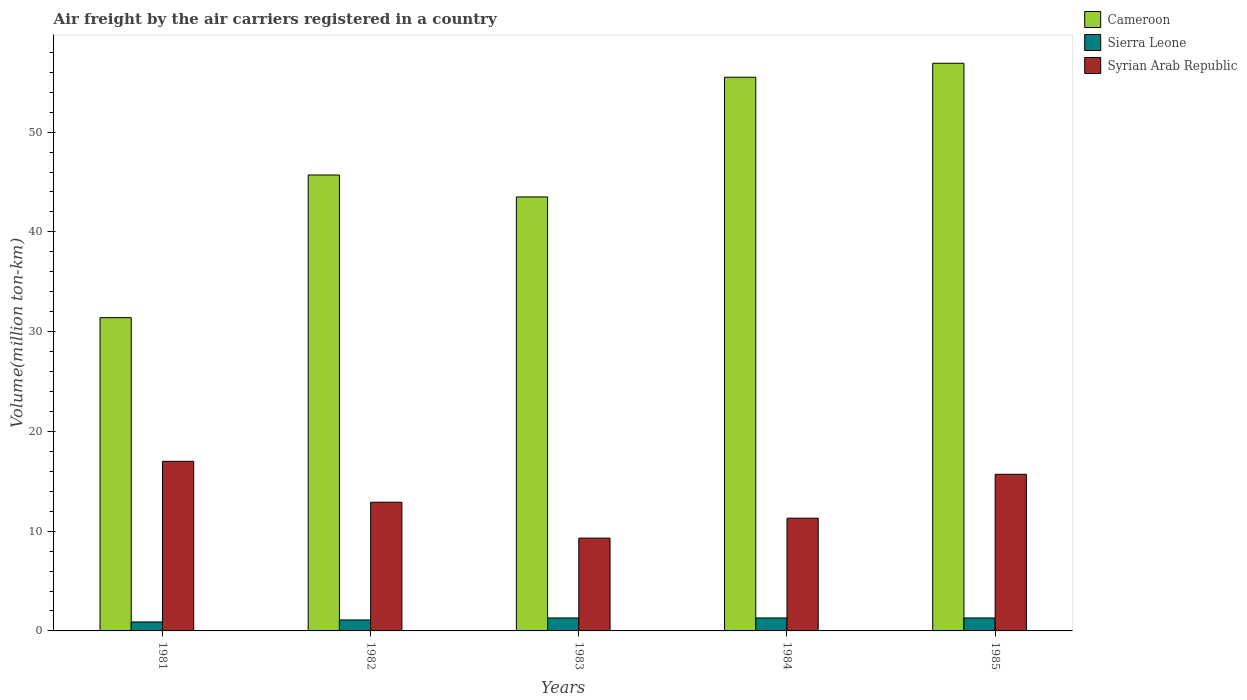How many different coloured bars are there?
Provide a short and direct response. 3. Are the number of bars per tick equal to the number of legend labels?
Provide a short and direct response. Yes. Are the number of bars on each tick of the X-axis equal?
Provide a short and direct response. Yes. How many bars are there on the 4th tick from the left?
Provide a short and direct response. 3. How many bars are there on the 1st tick from the right?
Your response must be concise. 3. What is the label of the 1st group of bars from the left?
Offer a terse response. 1981. In how many cases, is the number of bars for a given year not equal to the number of legend labels?
Your answer should be very brief. 0. What is the volume of the air carriers in Sierra Leone in 1984?
Provide a succinct answer. 1.3. Across all years, what is the maximum volume of the air carriers in Syrian Arab Republic?
Offer a very short reply. 17. Across all years, what is the minimum volume of the air carriers in Cameroon?
Offer a very short reply. 31.4. In which year was the volume of the air carriers in Sierra Leone maximum?
Your answer should be very brief. 1983. In which year was the volume of the air carriers in Cameroon minimum?
Offer a terse response. 1981. What is the total volume of the air carriers in Sierra Leone in the graph?
Your answer should be very brief. 5.9. What is the difference between the volume of the air carriers in Syrian Arab Republic in 1983 and that in 1984?
Offer a terse response. -2. What is the difference between the volume of the air carriers in Syrian Arab Republic in 1985 and the volume of the air carriers in Cameroon in 1984?
Your answer should be compact. -39.8. What is the average volume of the air carriers in Sierra Leone per year?
Offer a very short reply. 1.18. In the year 1984, what is the difference between the volume of the air carriers in Syrian Arab Republic and volume of the air carriers in Sierra Leone?
Your answer should be compact. 10. What is the ratio of the volume of the air carriers in Cameroon in 1981 to that in 1984?
Your response must be concise. 0.57. Is the difference between the volume of the air carriers in Syrian Arab Republic in 1981 and 1983 greater than the difference between the volume of the air carriers in Sierra Leone in 1981 and 1983?
Make the answer very short. Yes. What is the difference between the highest and the second highest volume of the air carriers in Syrian Arab Republic?
Offer a very short reply. 1.3. What is the difference between the highest and the lowest volume of the air carriers in Sierra Leone?
Your answer should be compact. 0.4. Is the sum of the volume of the air carriers in Sierra Leone in 1983 and 1985 greater than the maximum volume of the air carriers in Syrian Arab Republic across all years?
Give a very brief answer. No. What does the 2nd bar from the left in 1981 represents?
Your response must be concise. Sierra Leone. What does the 1st bar from the right in 1982 represents?
Your answer should be very brief. Syrian Arab Republic. Is it the case that in every year, the sum of the volume of the air carriers in Cameroon and volume of the air carriers in Syrian Arab Republic is greater than the volume of the air carriers in Sierra Leone?
Your answer should be very brief. Yes. How many bars are there?
Provide a short and direct response. 15. What is the difference between two consecutive major ticks on the Y-axis?
Your response must be concise. 10. Are the values on the major ticks of Y-axis written in scientific E-notation?
Provide a short and direct response. No. Does the graph contain any zero values?
Make the answer very short. No. Where does the legend appear in the graph?
Ensure brevity in your answer.  Top right. How many legend labels are there?
Give a very brief answer. 3. How are the legend labels stacked?
Your answer should be very brief. Vertical. What is the title of the graph?
Ensure brevity in your answer.  Air freight by the air carriers registered in a country. What is the label or title of the Y-axis?
Offer a terse response. Volume(million ton-km). What is the Volume(million ton-km) in Cameroon in 1981?
Your answer should be compact. 31.4. What is the Volume(million ton-km) of Sierra Leone in 1981?
Give a very brief answer. 0.9. What is the Volume(million ton-km) of Syrian Arab Republic in 1981?
Ensure brevity in your answer.  17. What is the Volume(million ton-km) in Cameroon in 1982?
Offer a terse response. 45.7. What is the Volume(million ton-km) in Sierra Leone in 1982?
Offer a terse response. 1.1. What is the Volume(million ton-km) in Syrian Arab Republic in 1982?
Provide a short and direct response. 12.9. What is the Volume(million ton-km) of Cameroon in 1983?
Your answer should be very brief. 43.5. What is the Volume(million ton-km) of Sierra Leone in 1983?
Your answer should be very brief. 1.3. What is the Volume(million ton-km) in Syrian Arab Republic in 1983?
Ensure brevity in your answer.  9.3. What is the Volume(million ton-km) of Cameroon in 1984?
Your answer should be compact. 55.5. What is the Volume(million ton-km) of Sierra Leone in 1984?
Your response must be concise. 1.3. What is the Volume(million ton-km) in Syrian Arab Republic in 1984?
Offer a very short reply. 11.3. What is the Volume(million ton-km) in Cameroon in 1985?
Offer a terse response. 56.9. What is the Volume(million ton-km) in Sierra Leone in 1985?
Provide a short and direct response. 1.3. What is the Volume(million ton-km) in Syrian Arab Republic in 1985?
Provide a succinct answer. 15.7. Across all years, what is the maximum Volume(million ton-km) in Cameroon?
Your response must be concise. 56.9. Across all years, what is the maximum Volume(million ton-km) of Sierra Leone?
Make the answer very short. 1.3. Across all years, what is the maximum Volume(million ton-km) in Syrian Arab Republic?
Provide a short and direct response. 17. Across all years, what is the minimum Volume(million ton-km) in Cameroon?
Offer a very short reply. 31.4. Across all years, what is the minimum Volume(million ton-km) in Sierra Leone?
Your response must be concise. 0.9. Across all years, what is the minimum Volume(million ton-km) of Syrian Arab Republic?
Keep it short and to the point. 9.3. What is the total Volume(million ton-km) in Cameroon in the graph?
Offer a terse response. 233. What is the total Volume(million ton-km) of Sierra Leone in the graph?
Offer a very short reply. 5.9. What is the total Volume(million ton-km) of Syrian Arab Republic in the graph?
Provide a short and direct response. 66.2. What is the difference between the Volume(million ton-km) in Cameroon in 1981 and that in 1982?
Give a very brief answer. -14.3. What is the difference between the Volume(million ton-km) in Syrian Arab Republic in 1981 and that in 1982?
Your response must be concise. 4.1. What is the difference between the Volume(million ton-km) of Sierra Leone in 1981 and that in 1983?
Provide a succinct answer. -0.4. What is the difference between the Volume(million ton-km) of Syrian Arab Republic in 1981 and that in 1983?
Offer a terse response. 7.7. What is the difference between the Volume(million ton-km) in Cameroon in 1981 and that in 1984?
Provide a short and direct response. -24.1. What is the difference between the Volume(million ton-km) in Syrian Arab Republic in 1981 and that in 1984?
Offer a very short reply. 5.7. What is the difference between the Volume(million ton-km) in Cameroon in 1981 and that in 1985?
Offer a terse response. -25.5. What is the difference between the Volume(million ton-km) in Syrian Arab Republic in 1982 and that in 1983?
Give a very brief answer. 3.6. What is the difference between the Volume(million ton-km) in Sierra Leone in 1982 and that in 1985?
Keep it short and to the point. -0.2. What is the difference between the Volume(million ton-km) in Cameroon in 1983 and that in 1984?
Provide a succinct answer. -12. What is the difference between the Volume(million ton-km) in Syrian Arab Republic in 1983 and that in 1984?
Provide a short and direct response. -2. What is the difference between the Volume(million ton-km) in Sierra Leone in 1983 and that in 1985?
Your answer should be very brief. 0. What is the difference between the Volume(million ton-km) of Cameroon in 1984 and that in 1985?
Your answer should be very brief. -1.4. What is the difference between the Volume(million ton-km) in Sierra Leone in 1984 and that in 1985?
Your answer should be very brief. 0. What is the difference between the Volume(million ton-km) in Cameroon in 1981 and the Volume(million ton-km) in Sierra Leone in 1982?
Offer a terse response. 30.3. What is the difference between the Volume(million ton-km) in Cameroon in 1981 and the Volume(million ton-km) in Sierra Leone in 1983?
Make the answer very short. 30.1. What is the difference between the Volume(million ton-km) of Cameroon in 1981 and the Volume(million ton-km) of Syrian Arab Republic in 1983?
Offer a very short reply. 22.1. What is the difference between the Volume(million ton-km) in Sierra Leone in 1981 and the Volume(million ton-km) in Syrian Arab Republic in 1983?
Your answer should be compact. -8.4. What is the difference between the Volume(million ton-km) of Cameroon in 1981 and the Volume(million ton-km) of Sierra Leone in 1984?
Your answer should be compact. 30.1. What is the difference between the Volume(million ton-km) of Cameroon in 1981 and the Volume(million ton-km) of Syrian Arab Republic in 1984?
Make the answer very short. 20.1. What is the difference between the Volume(million ton-km) in Sierra Leone in 1981 and the Volume(million ton-km) in Syrian Arab Republic in 1984?
Make the answer very short. -10.4. What is the difference between the Volume(million ton-km) of Cameroon in 1981 and the Volume(million ton-km) of Sierra Leone in 1985?
Ensure brevity in your answer.  30.1. What is the difference between the Volume(million ton-km) in Cameroon in 1981 and the Volume(million ton-km) in Syrian Arab Republic in 1985?
Ensure brevity in your answer.  15.7. What is the difference between the Volume(million ton-km) in Sierra Leone in 1981 and the Volume(million ton-km) in Syrian Arab Republic in 1985?
Your response must be concise. -14.8. What is the difference between the Volume(million ton-km) in Cameroon in 1982 and the Volume(million ton-km) in Sierra Leone in 1983?
Your answer should be very brief. 44.4. What is the difference between the Volume(million ton-km) in Cameroon in 1982 and the Volume(million ton-km) in Syrian Arab Republic in 1983?
Keep it short and to the point. 36.4. What is the difference between the Volume(million ton-km) in Sierra Leone in 1982 and the Volume(million ton-km) in Syrian Arab Republic in 1983?
Offer a terse response. -8.2. What is the difference between the Volume(million ton-km) of Cameroon in 1982 and the Volume(million ton-km) of Sierra Leone in 1984?
Provide a short and direct response. 44.4. What is the difference between the Volume(million ton-km) of Cameroon in 1982 and the Volume(million ton-km) of Syrian Arab Republic in 1984?
Your answer should be very brief. 34.4. What is the difference between the Volume(million ton-km) of Cameroon in 1982 and the Volume(million ton-km) of Sierra Leone in 1985?
Offer a terse response. 44.4. What is the difference between the Volume(million ton-km) in Sierra Leone in 1982 and the Volume(million ton-km) in Syrian Arab Republic in 1985?
Offer a terse response. -14.6. What is the difference between the Volume(million ton-km) of Cameroon in 1983 and the Volume(million ton-km) of Sierra Leone in 1984?
Your response must be concise. 42.2. What is the difference between the Volume(million ton-km) in Cameroon in 1983 and the Volume(million ton-km) in Syrian Arab Republic in 1984?
Give a very brief answer. 32.2. What is the difference between the Volume(million ton-km) in Cameroon in 1983 and the Volume(million ton-km) in Sierra Leone in 1985?
Keep it short and to the point. 42.2. What is the difference between the Volume(million ton-km) of Cameroon in 1983 and the Volume(million ton-km) of Syrian Arab Republic in 1985?
Offer a terse response. 27.8. What is the difference between the Volume(million ton-km) in Sierra Leone in 1983 and the Volume(million ton-km) in Syrian Arab Republic in 1985?
Provide a succinct answer. -14.4. What is the difference between the Volume(million ton-km) of Cameroon in 1984 and the Volume(million ton-km) of Sierra Leone in 1985?
Your answer should be very brief. 54.2. What is the difference between the Volume(million ton-km) of Cameroon in 1984 and the Volume(million ton-km) of Syrian Arab Republic in 1985?
Offer a very short reply. 39.8. What is the difference between the Volume(million ton-km) in Sierra Leone in 1984 and the Volume(million ton-km) in Syrian Arab Republic in 1985?
Ensure brevity in your answer.  -14.4. What is the average Volume(million ton-km) of Cameroon per year?
Offer a very short reply. 46.6. What is the average Volume(million ton-km) in Sierra Leone per year?
Make the answer very short. 1.18. What is the average Volume(million ton-km) of Syrian Arab Republic per year?
Make the answer very short. 13.24. In the year 1981, what is the difference between the Volume(million ton-km) of Cameroon and Volume(million ton-km) of Sierra Leone?
Your answer should be very brief. 30.5. In the year 1981, what is the difference between the Volume(million ton-km) in Sierra Leone and Volume(million ton-km) in Syrian Arab Republic?
Ensure brevity in your answer.  -16.1. In the year 1982, what is the difference between the Volume(million ton-km) of Cameroon and Volume(million ton-km) of Sierra Leone?
Your response must be concise. 44.6. In the year 1982, what is the difference between the Volume(million ton-km) of Cameroon and Volume(million ton-km) of Syrian Arab Republic?
Keep it short and to the point. 32.8. In the year 1983, what is the difference between the Volume(million ton-km) of Cameroon and Volume(million ton-km) of Sierra Leone?
Your answer should be compact. 42.2. In the year 1983, what is the difference between the Volume(million ton-km) in Cameroon and Volume(million ton-km) in Syrian Arab Republic?
Keep it short and to the point. 34.2. In the year 1984, what is the difference between the Volume(million ton-km) in Cameroon and Volume(million ton-km) in Sierra Leone?
Ensure brevity in your answer.  54.2. In the year 1984, what is the difference between the Volume(million ton-km) in Cameroon and Volume(million ton-km) in Syrian Arab Republic?
Offer a terse response. 44.2. In the year 1985, what is the difference between the Volume(million ton-km) in Cameroon and Volume(million ton-km) in Sierra Leone?
Your response must be concise. 55.6. In the year 1985, what is the difference between the Volume(million ton-km) in Cameroon and Volume(million ton-km) in Syrian Arab Republic?
Your response must be concise. 41.2. In the year 1985, what is the difference between the Volume(million ton-km) in Sierra Leone and Volume(million ton-km) in Syrian Arab Republic?
Give a very brief answer. -14.4. What is the ratio of the Volume(million ton-km) of Cameroon in 1981 to that in 1982?
Give a very brief answer. 0.69. What is the ratio of the Volume(million ton-km) in Sierra Leone in 1981 to that in 1982?
Your answer should be very brief. 0.82. What is the ratio of the Volume(million ton-km) in Syrian Arab Republic in 1981 to that in 1982?
Provide a succinct answer. 1.32. What is the ratio of the Volume(million ton-km) in Cameroon in 1981 to that in 1983?
Your answer should be very brief. 0.72. What is the ratio of the Volume(million ton-km) in Sierra Leone in 1981 to that in 1983?
Make the answer very short. 0.69. What is the ratio of the Volume(million ton-km) of Syrian Arab Republic in 1981 to that in 1983?
Provide a short and direct response. 1.83. What is the ratio of the Volume(million ton-km) in Cameroon in 1981 to that in 1984?
Your answer should be compact. 0.57. What is the ratio of the Volume(million ton-km) in Sierra Leone in 1981 to that in 1984?
Provide a short and direct response. 0.69. What is the ratio of the Volume(million ton-km) in Syrian Arab Republic in 1981 to that in 1984?
Ensure brevity in your answer.  1.5. What is the ratio of the Volume(million ton-km) in Cameroon in 1981 to that in 1985?
Offer a very short reply. 0.55. What is the ratio of the Volume(million ton-km) of Sierra Leone in 1981 to that in 1985?
Ensure brevity in your answer.  0.69. What is the ratio of the Volume(million ton-km) in Syrian Arab Republic in 1981 to that in 1985?
Offer a terse response. 1.08. What is the ratio of the Volume(million ton-km) of Cameroon in 1982 to that in 1983?
Offer a very short reply. 1.05. What is the ratio of the Volume(million ton-km) in Sierra Leone in 1982 to that in 1983?
Your answer should be compact. 0.85. What is the ratio of the Volume(million ton-km) in Syrian Arab Republic in 1982 to that in 1983?
Offer a very short reply. 1.39. What is the ratio of the Volume(million ton-km) of Cameroon in 1982 to that in 1984?
Provide a succinct answer. 0.82. What is the ratio of the Volume(million ton-km) of Sierra Leone in 1982 to that in 1984?
Your answer should be compact. 0.85. What is the ratio of the Volume(million ton-km) of Syrian Arab Republic in 1982 to that in 1984?
Give a very brief answer. 1.14. What is the ratio of the Volume(million ton-km) in Cameroon in 1982 to that in 1985?
Make the answer very short. 0.8. What is the ratio of the Volume(million ton-km) of Sierra Leone in 1982 to that in 1985?
Make the answer very short. 0.85. What is the ratio of the Volume(million ton-km) in Syrian Arab Republic in 1982 to that in 1985?
Your answer should be very brief. 0.82. What is the ratio of the Volume(million ton-km) of Cameroon in 1983 to that in 1984?
Offer a very short reply. 0.78. What is the ratio of the Volume(million ton-km) of Syrian Arab Republic in 1983 to that in 1984?
Make the answer very short. 0.82. What is the ratio of the Volume(million ton-km) in Cameroon in 1983 to that in 1985?
Provide a short and direct response. 0.76. What is the ratio of the Volume(million ton-km) in Sierra Leone in 1983 to that in 1985?
Ensure brevity in your answer.  1. What is the ratio of the Volume(million ton-km) in Syrian Arab Republic in 1983 to that in 1985?
Offer a very short reply. 0.59. What is the ratio of the Volume(million ton-km) of Cameroon in 1984 to that in 1985?
Make the answer very short. 0.98. What is the ratio of the Volume(million ton-km) of Sierra Leone in 1984 to that in 1985?
Provide a succinct answer. 1. What is the ratio of the Volume(million ton-km) in Syrian Arab Republic in 1984 to that in 1985?
Your response must be concise. 0.72. What is the difference between the highest and the second highest Volume(million ton-km) of Cameroon?
Give a very brief answer. 1.4. What is the difference between the highest and the second highest Volume(million ton-km) of Syrian Arab Republic?
Your response must be concise. 1.3. What is the difference between the highest and the lowest Volume(million ton-km) in Sierra Leone?
Keep it short and to the point. 0.4. 